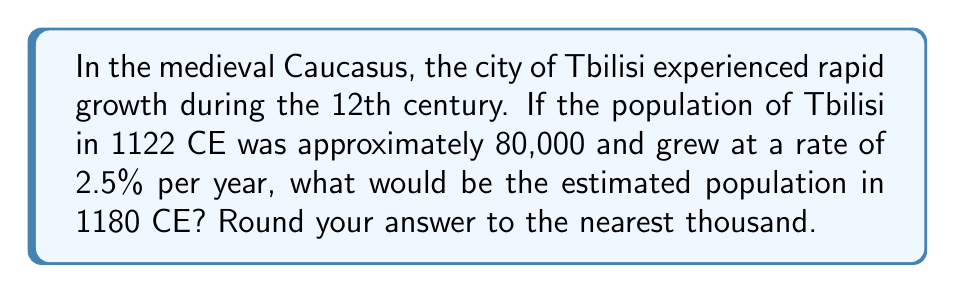Provide a solution to this math problem. To solve this problem, we'll use the exponential growth model:

$$ A = P(1 + r)^t $$

Where:
$A$ = final amount
$P$ = initial population
$r$ = growth rate (as a decimal)
$t$ = time in years

Given:
$P = 80,000$ (initial population in 1122 CE)
$r = 0.025$ (2.5% converted to decimal)
$t = 58$ (years from 1122 to 1180)

Let's plug these values into our equation:

$$ A = 80,000(1 + 0.025)^{58} $$

Now, let's calculate:

1) First, simplify the base of the exponent:
   $1 + 0.025 = 1.025$

2) Our equation now looks like:
   $$ A = 80,000(1.025)^{58} $$

3) Calculate $(1.025)^{58}$:
   $(1.025)^{58} \approx 4.1559$

4) Multiply by 80,000:
   $80,000 \times 4.1559 = 332,472$

5) Round to the nearest thousand:
   332,472 ≈ 332,000

Therefore, the estimated population of Tbilisi in 1180 CE would be approximately 332,000.
Answer: 332,000 